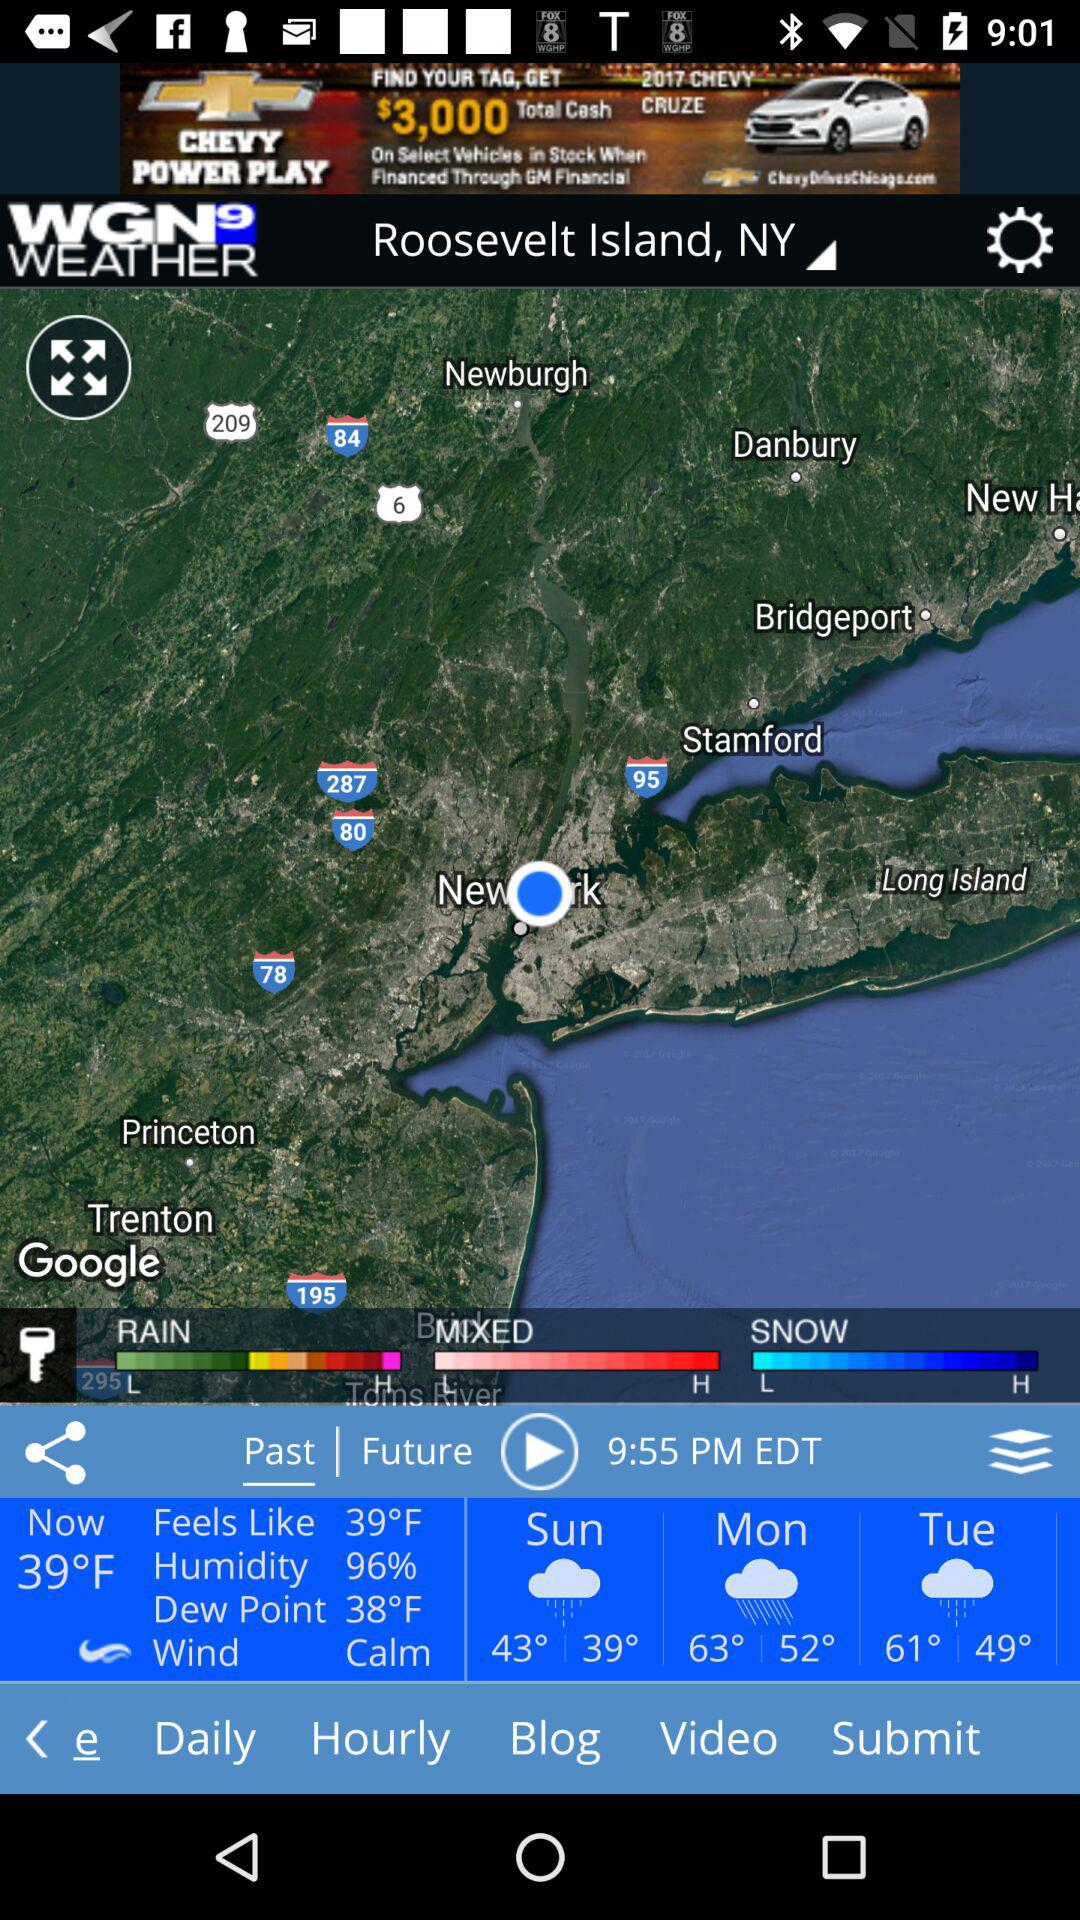How many different weather conditions are shown?
Answer the question using a single word or phrase. 3 